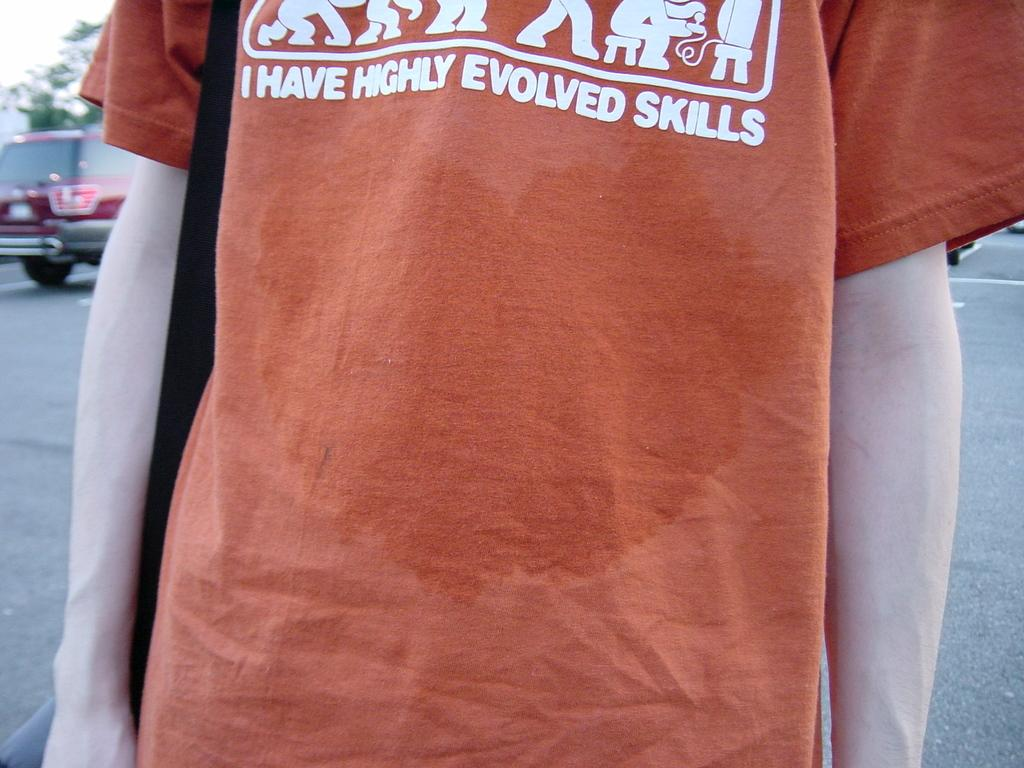<image>
Write a terse but informative summary of the picture. a picture of an orange tee shirt bearing the slogal 'I have highly evolved skills.' 